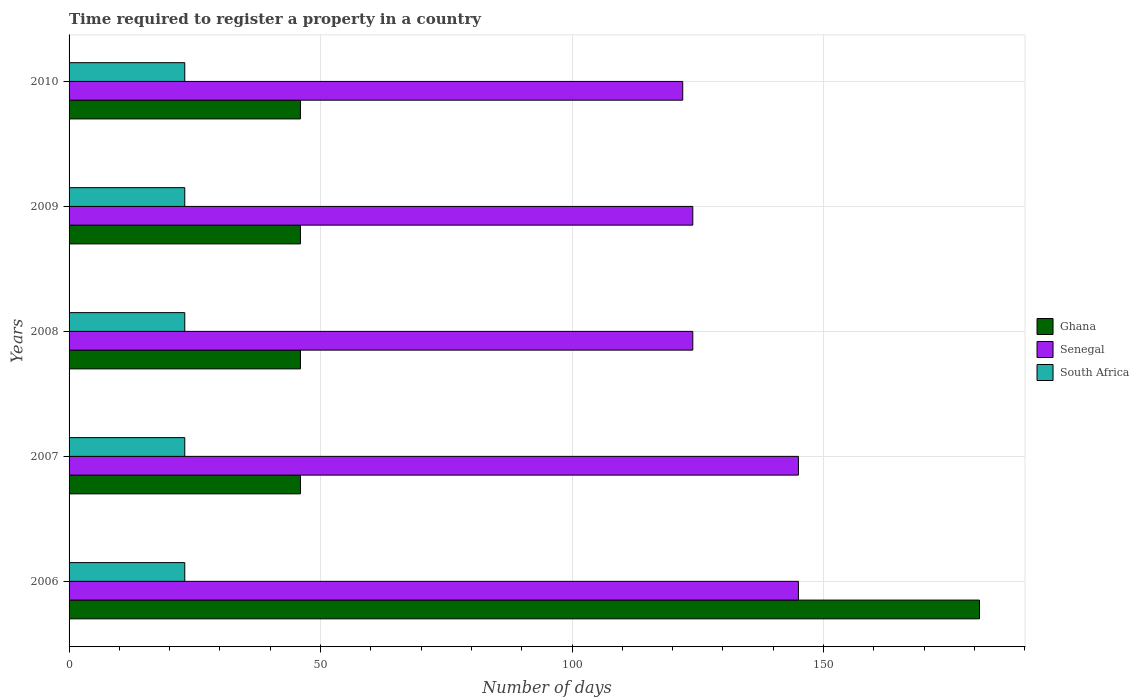Are the number of bars per tick equal to the number of legend labels?
Provide a succinct answer. Yes. Are the number of bars on each tick of the Y-axis equal?
Your response must be concise. Yes. How many bars are there on the 1st tick from the bottom?
Provide a short and direct response. 3. What is the label of the 5th group of bars from the top?
Offer a very short reply. 2006. In how many cases, is the number of bars for a given year not equal to the number of legend labels?
Your answer should be compact. 0. What is the number of days required to register a property in Ghana in 2008?
Provide a succinct answer. 46. Across all years, what is the maximum number of days required to register a property in South Africa?
Keep it short and to the point. 23. Across all years, what is the minimum number of days required to register a property in Senegal?
Keep it short and to the point. 122. In which year was the number of days required to register a property in Senegal maximum?
Provide a short and direct response. 2006. In which year was the number of days required to register a property in South Africa minimum?
Give a very brief answer. 2006. What is the total number of days required to register a property in Ghana in the graph?
Keep it short and to the point. 365. What is the difference between the number of days required to register a property in Senegal in 2006 and that in 2007?
Offer a very short reply. 0. What is the difference between the number of days required to register a property in Ghana in 2006 and the number of days required to register a property in South Africa in 2008?
Offer a terse response. 158. What is the average number of days required to register a property in Ghana per year?
Keep it short and to the point. 73. In the year 2006, what is the difference between the number of days required to register a property in Ghana and number of days required to register a property in South Africa?
Your answer should be very brief. 158. In how many years, is the number of days required to register a property in Senegal greater than 100 days?
Make the answer very short. 5. What is the ratio of the number of days required to register a property in South Africa in 2008 to that in 2009?
Give a very brief answer. 1. What is the difference between the highest and the lowest number of days required to register a property in Senegal?
Your response must be concise. 23. In how many years, is the number of days required to register a property in South Africa greater than the average number of days required to register a property in South Africa taken over all years?
Offer a terse response. 0. What does the 2nd bar from the top in 2007 represents?
Offer a terse response. Senegal. What does the 3rd bar from the bottom in 2007 represents?
Offer a very short reply. South Africa. Where does the legend appear in the graph?
Make the answer very short. Center right. What is the title of the graph?
Provide a succinct answer. Time required to register a property in a country. Does "American Samoa" appear as one of the legend labels in the graph?
Make the answer very short. No. What is the label or title of the X-axis?
Provide a succinct answer. Number of days. What is the label or title of the Y-axis?
Ensure brevity in your answer.  Years. What is the Number of days of Ghana in 2006?
Your answer should be very brief. 181. What is the Number of days of Senegal in 2006?
Give a very brief answer. 145. What is the Number of days in Ghana in 2007?
Offer a very short reply. 46. What is the Number of days in Senegal in 2007?
Provide a short and direct response. 145. What is the Number of days in South Africa in 2007?
Offer a very short reply. 23. What is the Number of days of Senegal in 2008?
Make the answer very short. 124. What is the Number of days of Senegal in 2009?
Give a very brief answer. 124. What is the Number of days of Senegal in 2010?
Your response must be concise. 122. What is the Number of days in South Africa in 2010?
Your answer should be compact. 23. Across all years, what is the maximum Number of days in Ghana?
Offer a very short reply. 181. Across all years, what is the maximum Number of days of Senegal?
Offer a terse response. 145. Across all years, what is the minimum Number of days of Senegal?
Offer a terse response. 122. What is the total Number of days in Ghana in the graph?
Your response must be concise. 365. What is the total Number of days in Senegal in the graph?
Offer a very short reply. 660. What is the total Number of days in South Africa in the graph?
Keep it short and to the point. 115. What is the difference between the Number of days of Ghana in 2006 and that in 2007?
Ensure brevity in your answer.  135. What is the difference between the Number of days in Senegal in 2006 and that in 2007?
Keep it short and to the point. 0. What is the difference between the Number of days of South Africa in 2006 and that in 2007?
Your answer should be very brief. 0. What is the difference between the Number of days in Ghana in 2006 and that in 2008?
Your answer should be very brief. 135. What is the difference between the Number of days in Senegal in 2006 and that in 2008?
Your response must be concise. 21. What is the difference between the Number of days of South Africa in 2006 and that in 2008?
Keep it short and to the point. 0. What is the difference between the Number of days in Ghana in 2006 and that in 2009?
Keep it short and to the point. 135. What is the difference between the Number of days in South Africa in 2006 and that in 2009?
Your answer should be compact. 0. What is the difference between the Number of days in Ghana in 2006 and that in 2010?
Keep it short and to the point. 135. What is the difference between the Number of days in Senegal in 2006 and that in 2010?
Provide a succinct answer. 23. What is the difference between the Number of days in Ghana in 2007 and that in 2009?
Your answer should be very brief. 0. What is the difference between the Number of days of Ghana in 2007 and that in 2010?
Offer a terse response. 0. What is the difference between the Number of days of Senegal in 2007 and that in 2010?
Keep it short and to the point. 23. What is the difference between the Number of days of Ghana in 2008 and that in 2009?
Provide a succinct answer. 0. What is the difference between the Number of days in Ghana in 2008 and that in 2010?
Provide a short and direct response. 0. What is the difference between the Number of days in Senegal in 2008 and that in 2010?
Keep it short and to the point. 2. What is the difference between the Number of days in South Africa in 2008 and that in 2010?
Keep it short and to the point. 0. What is the difference between the Number of days of Ghana in 2009 and that in 2010?
Your answer should be compact. 0. What is the difference between the Number of days of Ghana in 2006 and the Number of days of South Africa in 2007?
Your answer should be compact. 158. What is the difference between the Number of days of Senegal in 2006 and the Number of days of South Africa in 2007?
Keep it short and to the point. 122. What is the difference between the Number of days in Ghana in 2006 and the Number of days in South Africa in 2008?
Keep it short and to the point. 158. What is the difference between the Number of days in Senegal in 2006 and the Number of days in South Africa in 2008?
Give a very brief answer. 122. What is the difference between the Number of days in Ghana in 2006 and the Number of days in South Africa in 2009?
Provide a short and direct response. 158. What is the difference between the Number of days of Senegal in 2006 and the Number of days of South Africa in 2009?
Your response must be concise. 122. What is the difference between the Number of days in Ghana in 2006 and the Number of days in South Africa in 2010?
Offer a terse response. 158. What is the difference between the Number of days of Senegal in 2006 and the Number of days of South Africa in 2010?
Your response must be concise. 122. What is the difference between the Number of days of Ghana in 2007 and the Number of days of Senegal in 2008?
Your response must be concise. -78. What is the difference between the Number of days in Ghana in 2007 and the Number of days in South Africa in 2008?
Keep it short and to the point. 23. What is the difference between the Number of days in Senegal in 2007 and the Number of days in South Africa in 2008?
Offer a terse response. 122. What is the difference between the Number of days in Ghana in 2007 and the Number of days in Senegal in 2009?
Your answer should be very brief. -78. What is the difference between the Number of days in Senegal in 2007 and the Number of days in South Africa in 2009?
Give a very brief answer. 122. What is the difference between the Number of days of Ghana in 2007 and the Number of days of Senegal in 2010?
Your answer should be very brief. -76. What is the difference between the Number of days of Senegal in 2007 and the Number of days of South Africa in 2010?
Your response must be concise. 122. What is the difference between the Number of days of Ghana in 2008 and the Number of days of Senegal in 2009?
Offer a very short reply. -78. What is the difference between the Number of days in Senegal in 2008 and the Number of days in South Africa in 2009?
Offer a terse response. 101. What is the difference between the Number of days in Ghana in 2008 and the Number of days in Senegal in 2010?
Your answer should be compact. -76. What is the difference between the Number of days in Senegal in 2008 and the Number of days in South Africa in 2010?
Make the answer very short. 101. What is the difference between the Number of days of Ghana in 2009 and the Number of days of Senegal in 2010?
Provide a succinct answer. -76. What is the difference between the Number of days in Ghana in 2009 and the Number of days in South Africa in 2010?
Ensure brevity in your answer.  23. What is the difference between the Number of days of Senegal in 2009 and the Number of days of South Africa in 2010?
Your answer should be very brief. 101. What is the average Number of days of Senegal per year?
Offer a very short reply. 132. What is the average Number of days in South Africa per year?
Make the answer very short. 23. In the year 2006, what is the difference between the Number of days in Ghana and Number of days in Senegal?
Make the answer very short. 36. In the year 2006, what is the difference between the Number of days of Ghana and Number of days of South Africa?
Keep it short and to the point. 158. In the year 2006, what is the difference between the Number of days of Senegal and Number of days of South Africa?
Provide a succinct answer. 122. In the year 2007, what is the difference between the Number of days in Ghana and Number of days in Senegal?
Your answer should be compact. -99. In the year 2007, what is the difference between the Number of days of Ghana and Number of days of South Africa?
Provide a succinct answer. 23. In the year 2007, what is the difference between the Number of days in Senegal and Number of days in South Africa?
Keep it short and to the point. 122. In the year 2008, what is the difference between the Number of days in Ghana and Number of days in Senegal?
Provide a succinct answer. -78. In the year 2008, what is the difference between the Number of days of Ghana and Number of days of South Africa?
Offer a terse response. 23. In the year 2008, what is the difference between the Number of days in Senegal and Number of days in South Africa?
Offer a very short reply. 101. In the year 2009, what is the difference between the Number of days in Ghana and Number of days in Senegal?
Offer a very short reply. -78. In the year 2009, what is the difference between the Number of days of Senegal and Number of days of South Africa?
Offer a terse response. 101. In the year 2010, what is the difference between the Number of days of Ghana and Number of days of Senegal?
Keep it short and to the point. -76. What is the ratio of the Number of days of Ghana in 2006 to that in 2007?
Your answer should be very brief. 3.93. What is the ratio of the Number of days of Senegal in 2006 to that in 2007?
Make the answer very short. 1. What is the ratio of the Number of days in Ghana in 2006 to that in 2008?
Ensure brevity in your answer.  3.93. What is the ratio of the Number of days in Senegal in 2006 to that in 2008?
Give a very brief answer. 1.17. What is the ratio of the Number of days of Ghana in 2006 to that in 2009?
Your answer should be very brief. 3.93. What is the ratio of the Number of days of Senegal in 2006 to that in 2009?
Offer a terse response. 1.17. What is the ratio of the Number of days in Ghana in 2006 to that in 2010?
Give a very brief answer. 3.93. What is the ratio of the Number of days in Senegal in 2006 to that in 2010?
Your response must be concise. 1.19. What is the ratio of the Number of days in South Africa in 2006 to that in 2010?
Give a very brief answer. 1. What is the ratio of the Number of days in Senegal in 2007 to that in 2008?
Your response must be concise. 1.17. What is the ratio of the Number of days of Ghana in 2007 to that in 2009?
Make the answer very short. 1. What is the ratio of the Number of days of Senegal in 2007 to that in 2009?
Your answer should be very brief. 1.17. What is the ratio of the Number of days in South Africa in 2007 to that in 2009?
Provide a short and direct response. 1. What is the ratio of the Number of days in Senegal in 2007 to that in 2010?
Your answer should be very brief. 1.19. What is the ratio of the Number of days of South Africa in 2007 to that in 2010?
Keep it short and to the point. 1. What is the ratio of the Number of days in Ghana in 2008 to that in 2009?
Your response must be concise. 1. What is the ratio of the Number of days of South Africa in 2008 to that in 2009?
Provide a succinct answer. 1. What is the ratio of the Number of days of Senegal in 2008 to that in 2010?
Make the answer very short. 1.02. What is the ratio of the Number of days of Senegal in 2009 to that in 2010?
Keep it short and to the point. 1.02. What is the difference between the highest and the second highest Number of days of Ghana?
Your answer should be very brief. 135. What is the difference between the highest and the second highest Number of days of South Africa?
Provide a short and direct response. 0. What is the difference between the highest and the lowest Number of days of Ghana?
Provide a succinct answer. 135. What is the difference between the highest and the lowest Number of days in South Africa?
Ensure brevity in your answer.  0. 